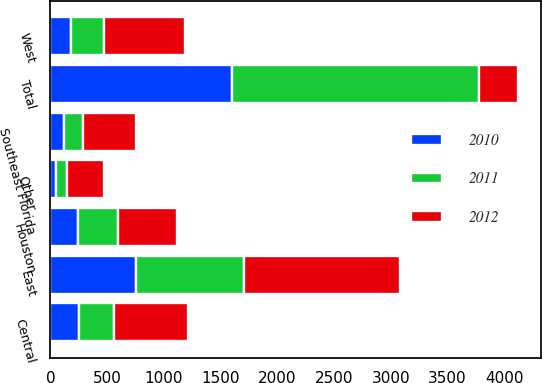Convert chart. <chart><loc_0><loc_0><loc_500><loc_500><stacked_bar_chart><ecel><fcel>East<fcel>Central<fcel>West<fcel>Southeast Florida<fcel>Houston<fcel>Other<fcel>Total<nl><fcel>2012<fcel>1376<fcel>653<fcel>708<fcel>469<fcel>516<fcel>331<fcel>343<nl><fcel>2011<fcel>948<fcel>309<fcel>298<fcel>166<fcel>355<fcel>95<fcel>2171<nl><fcel>2010<fcel>755<fcel>254<fcel>179<fcel>123<fcel>245<fcel>48<fcel>1604<nl></chart> 